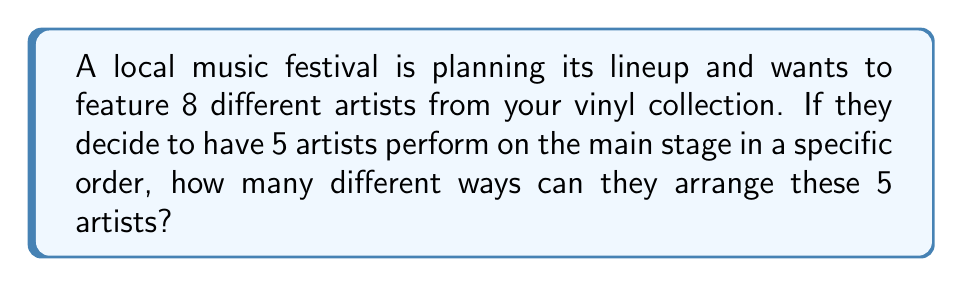Teach me how to tackle this problem. Let's approach this step-by-step:

1) We are selecting 5 artists out of 8 to perform on the main stage.

2) The order of performance matters, which means we are dealing with a permutation rather than a combination.

3) Since we are selecting 5 artists out of 8, and the order matters, this is a permutation without repetition.

4) The formula for permutations without repetition is:

   $$P(n,r) = \frac{n!}{(n-r)!}$$

   Where $n$ is the total number of items to choose from, and $r$ is the number of items being chosen.

5) In this case, $n = 8$ (total artists) and $r = 5$ (artists on main stage).

6) Plugging these values into our formula:

   $$P(8,5) = \frac{8!}{(8-5)!} = \frac{8!}{3!}$$

7) Expanding this:
   
   $$\frac{8 * 7 * 6 * 5 * 4 * 3!}{3!}$$

8) The $3!$ cancels out in the numerator and denominator:

   $$8 * 7 * 6 * 5 * 4 = 6720$$

Therefore, there are 6720 different ways to arrange 5 artists out of 8 for the main stage lineup.
Answer: 6720 